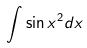<formula> <loc_0><loc_0><loc_500><loc_500>\int \sin x ^ { 2 } d x</formula> 